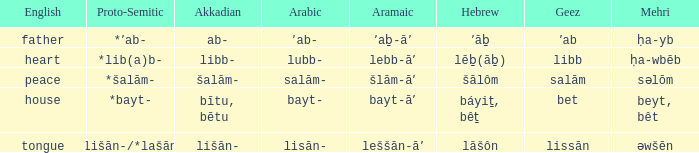If the aramaic is šlām-āʼ, what is the english? Peace. 